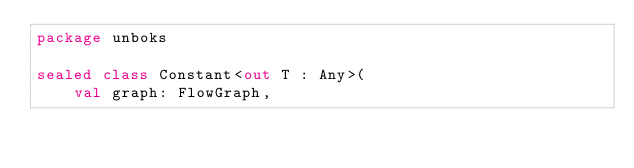Convert code to text. <code><loc_0><loc_0><loc_500><loc_500><_Kotlin_>package unboks

sealed class Constant<out T : Any>(
		val graph: FlowGraph,</code> 